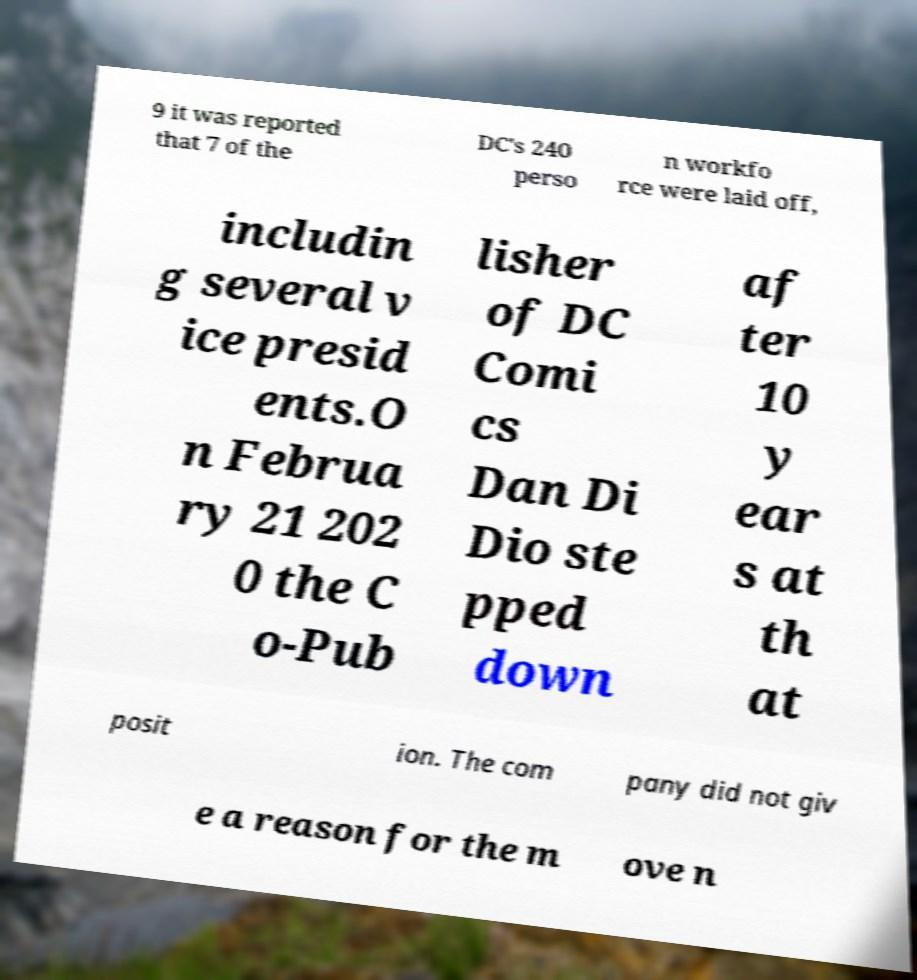Could you assist in decoding the text presented in this image and type it out clearly? 9 it was reported that 7 of the DC's 240 perso n workfo rce were laid off, includin g several v ice presid ents.O n Februa ry 21 202 0 the C o-Pub lisher of DC Comi cs Dan Di Dio ste pped down af ter 10 y ear s at th at posit ion. The com pany did not giv e a reason for the m ove n 